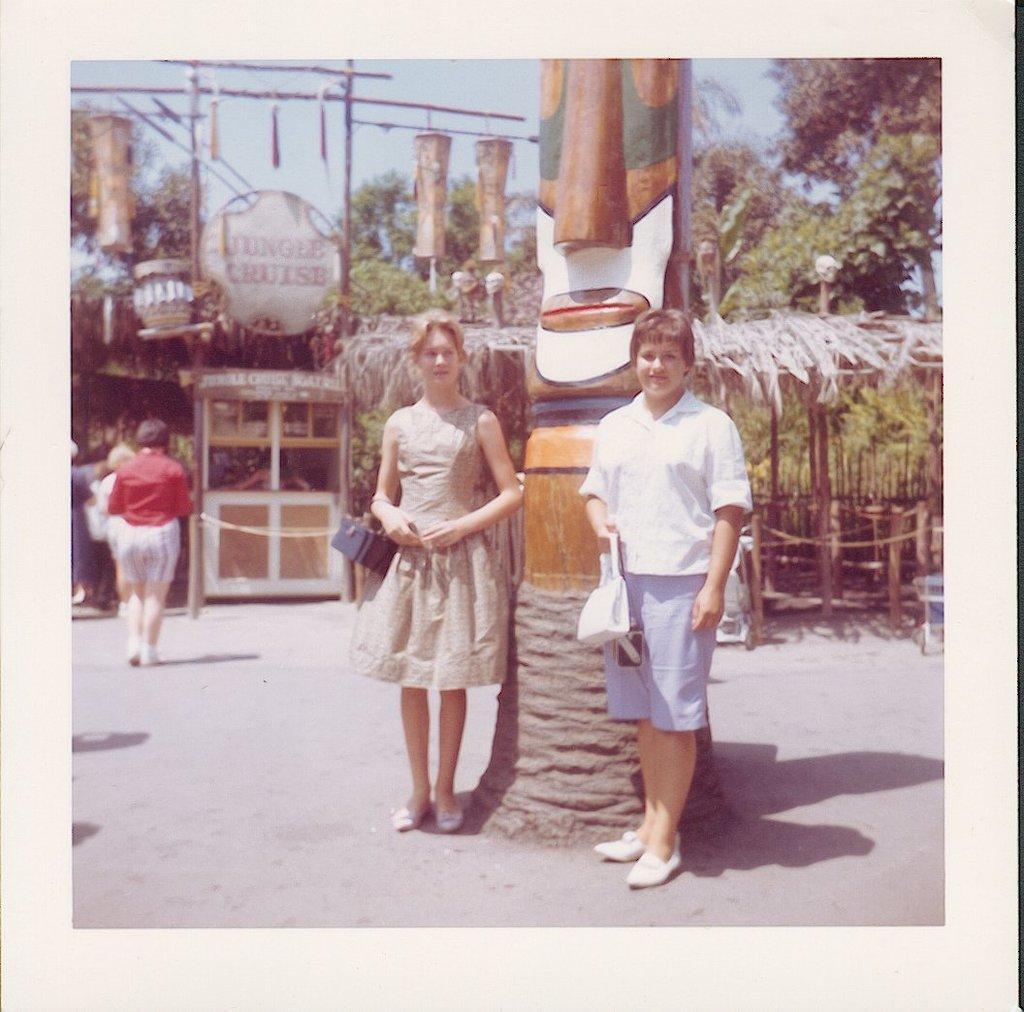In one or two sentences, can you explain what this image depicts? In the image we can see there are people standing and some of them are walking, they are wearing clothes and shoes. Here we can see the road, sculpture and the hut. Here we can see the trees, poster and the sky. 